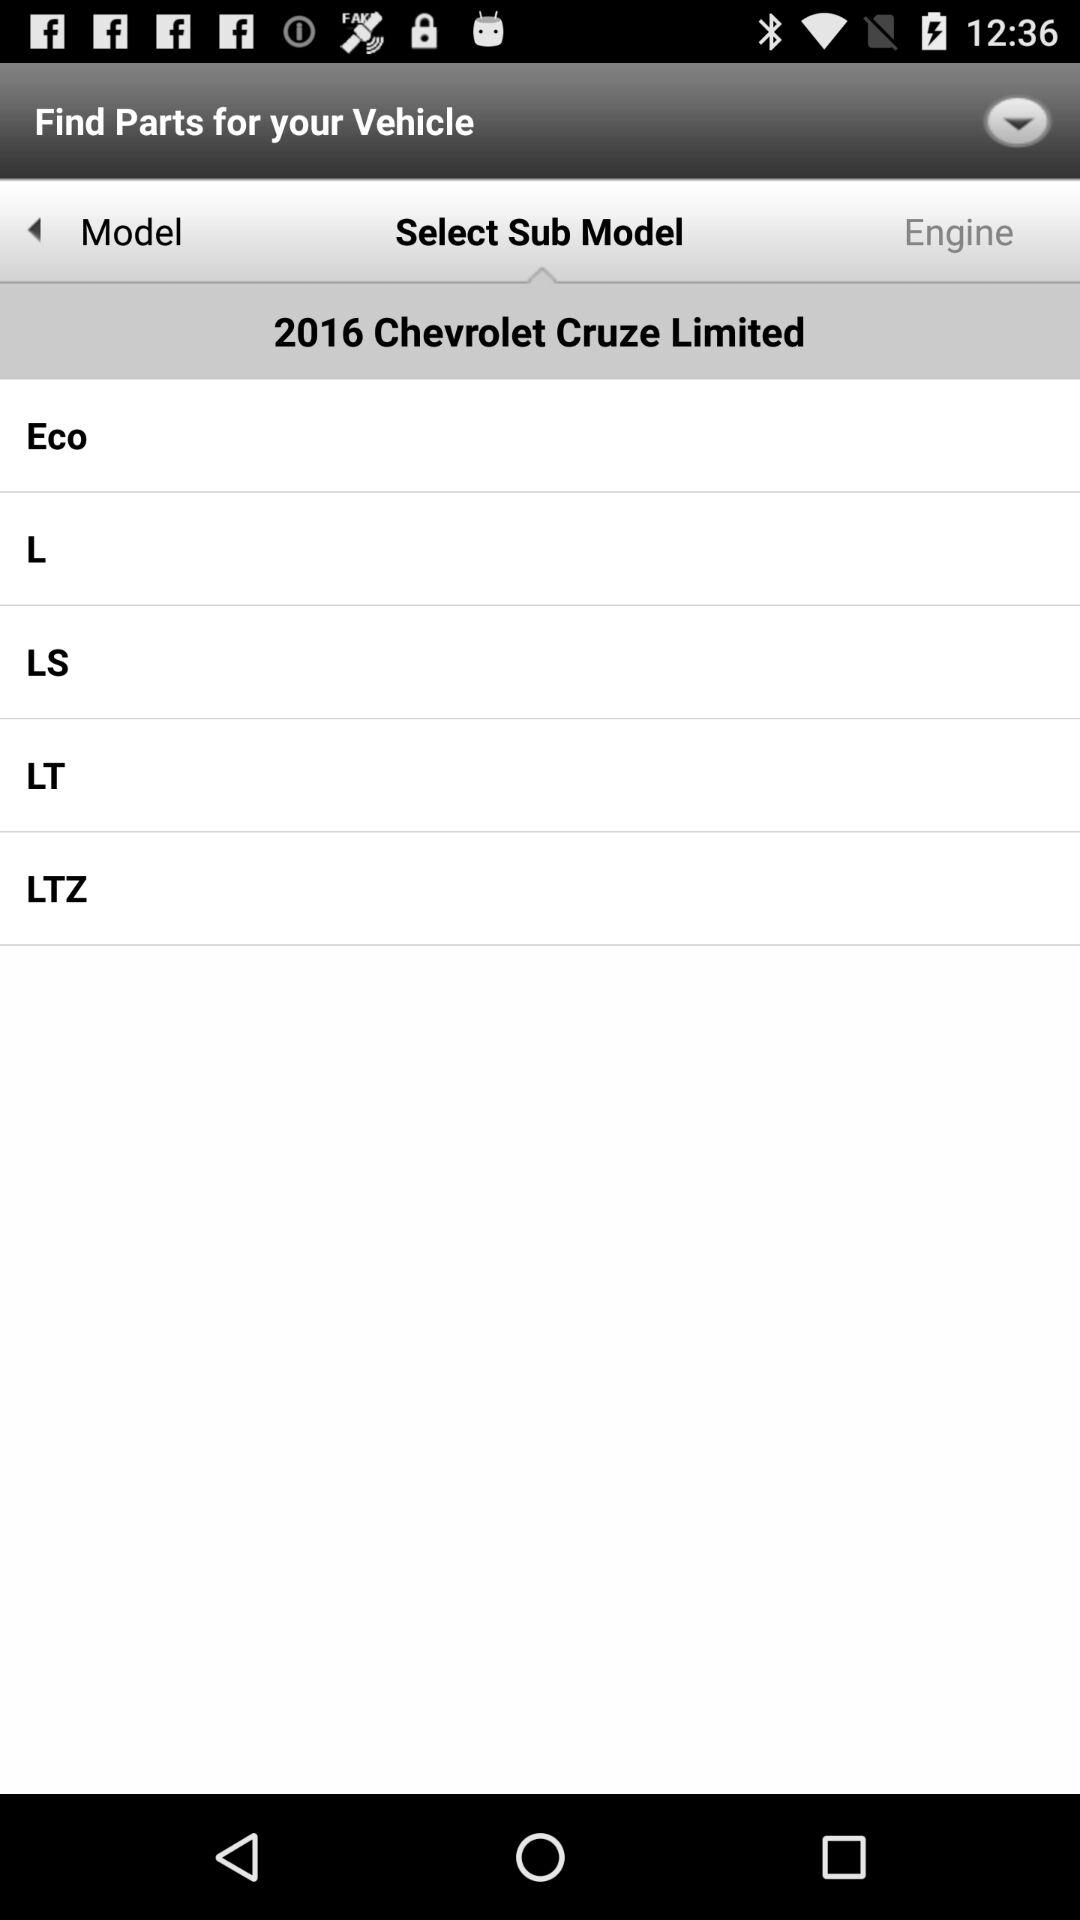How many sub-models are available for the 2016 Chevrolet Cruze Limited?
Answer the question using a single word or phrase. 5 